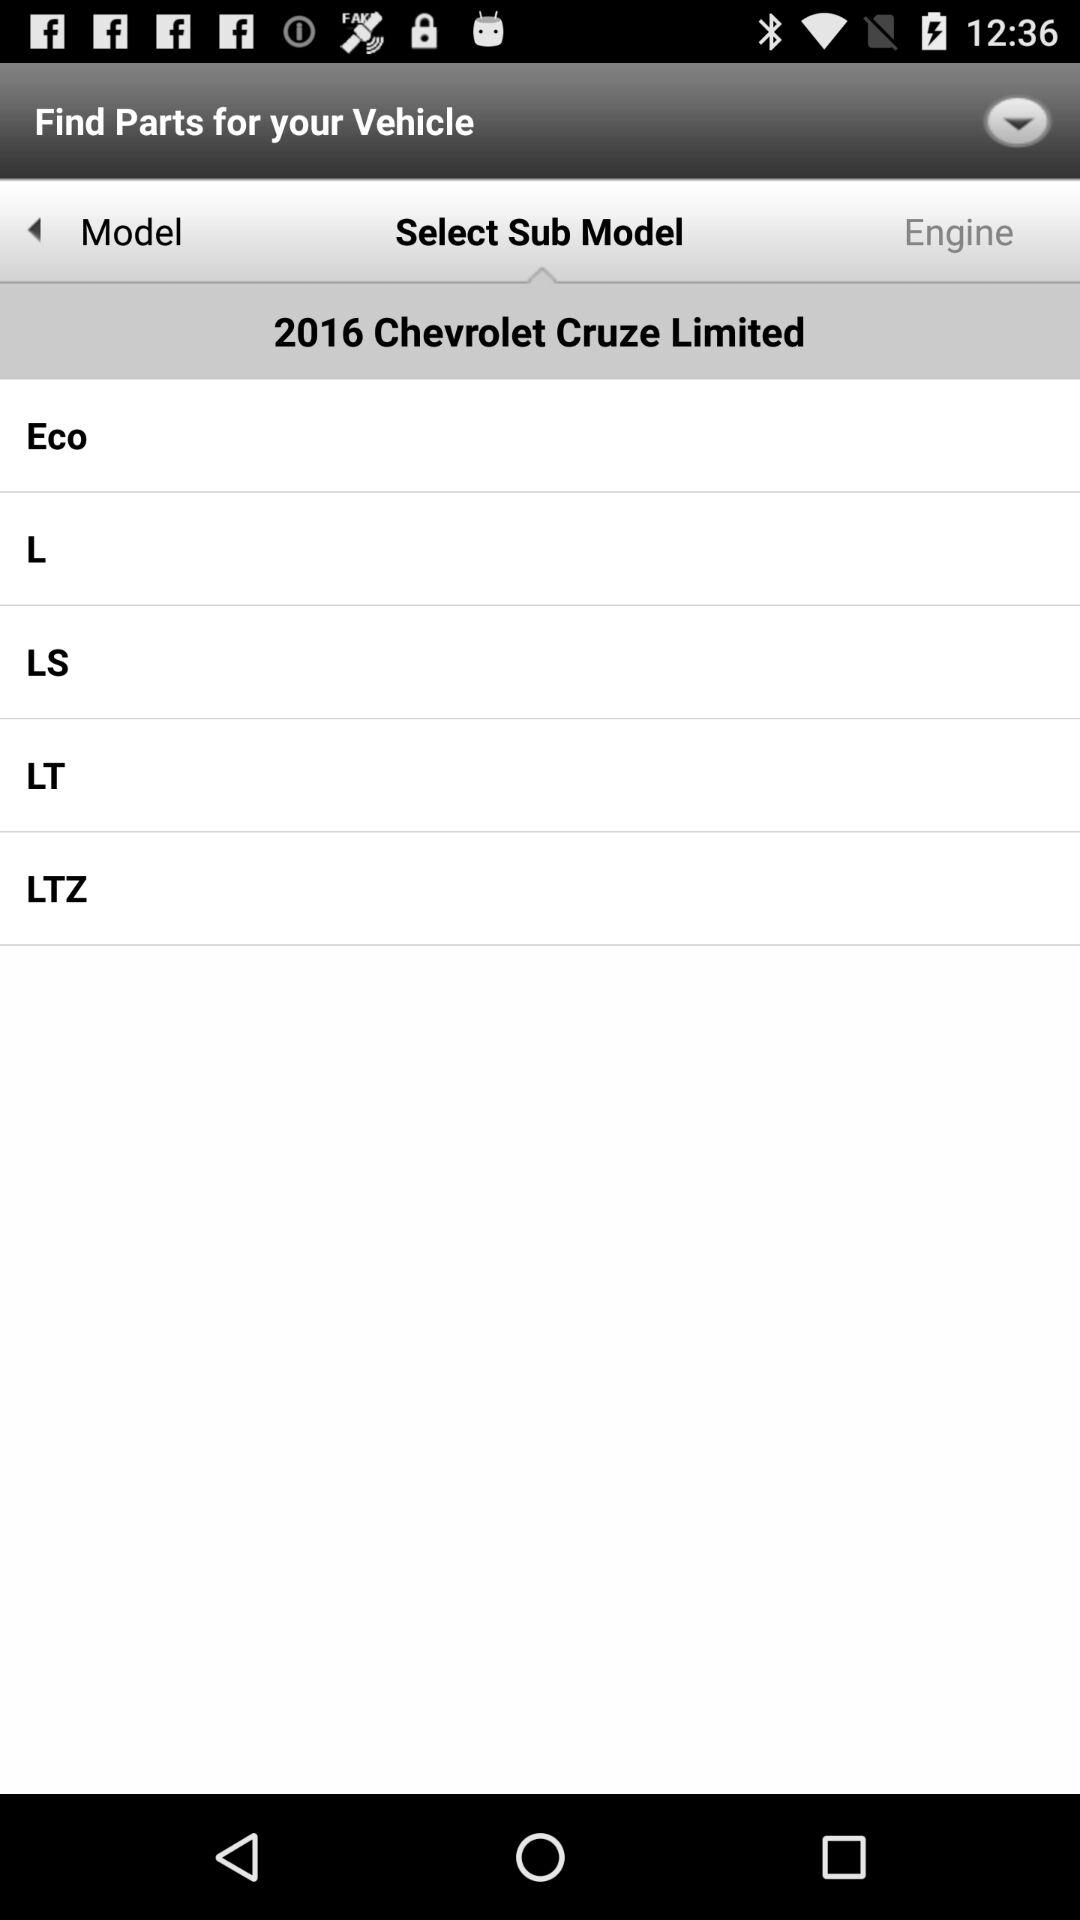How many sub-models are available for the 2016 Chevrolet Cruze Limited?
Answer the question using a single word or phrase. 5 